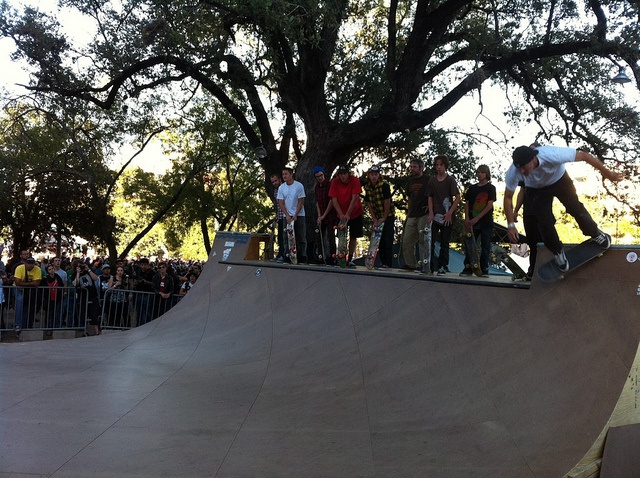Describe the objects in this image and their specific colors. I can see people in ivory, black, gray, and maroon tones, people in ivory, black, gray, and maroon tones, people in ivory, black, and gray tones, people in ivory, black, maroon, gray, and blue tones, and people in ivory, black, maroon, and gray tones in this image. 